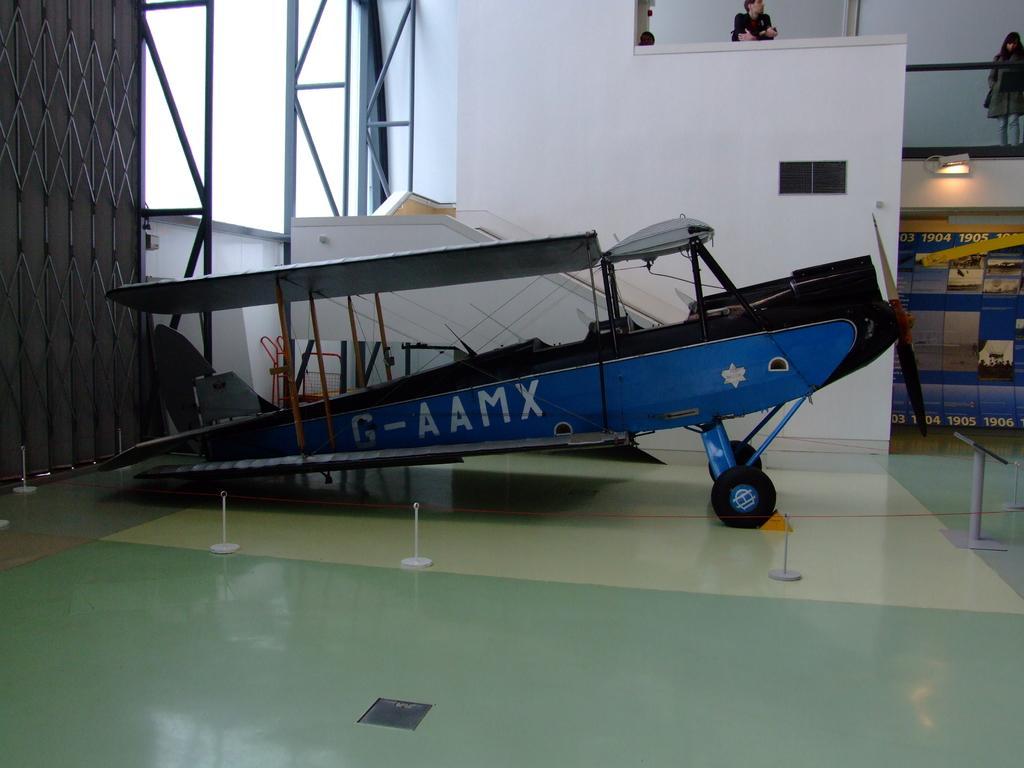In one or two sentences, can you explain what this image depicts? This picture might be taken inside the room. In this image, on the left side, we can see a metal grills. In the middle of the image, we can see a vehicle. On the right side, we can see a hoarding. In the background, we can see a wall, window and two people man and woman are standing. At the bottom, we can see a floor. 